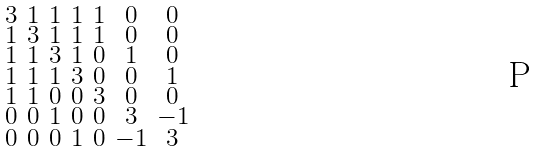<formula> <loc_0><loc_0><loc_500><loc_500>\begin{smallmatrix} 3 & 1 & 1 & 1 & 1 & 0 & 0 \\ 1 & 3 & 1 & 1 & 1 & 0 & 0 \\ 1 & 1 & 3 & 1 & 0 & 1 & 0 \\ 1 & 1 & 1 & 3 & 0 & 0 & 1 \\ 1 & 1 & 0 & 0 & 3 & 0 & 0 \\ 0 & 0 & 1 & 0 & 0 & 3 & - 1 \\ 0 & 0 & 0 & 1 & 0 & - 1 & 3 \end{smallmatrix}</formula> 